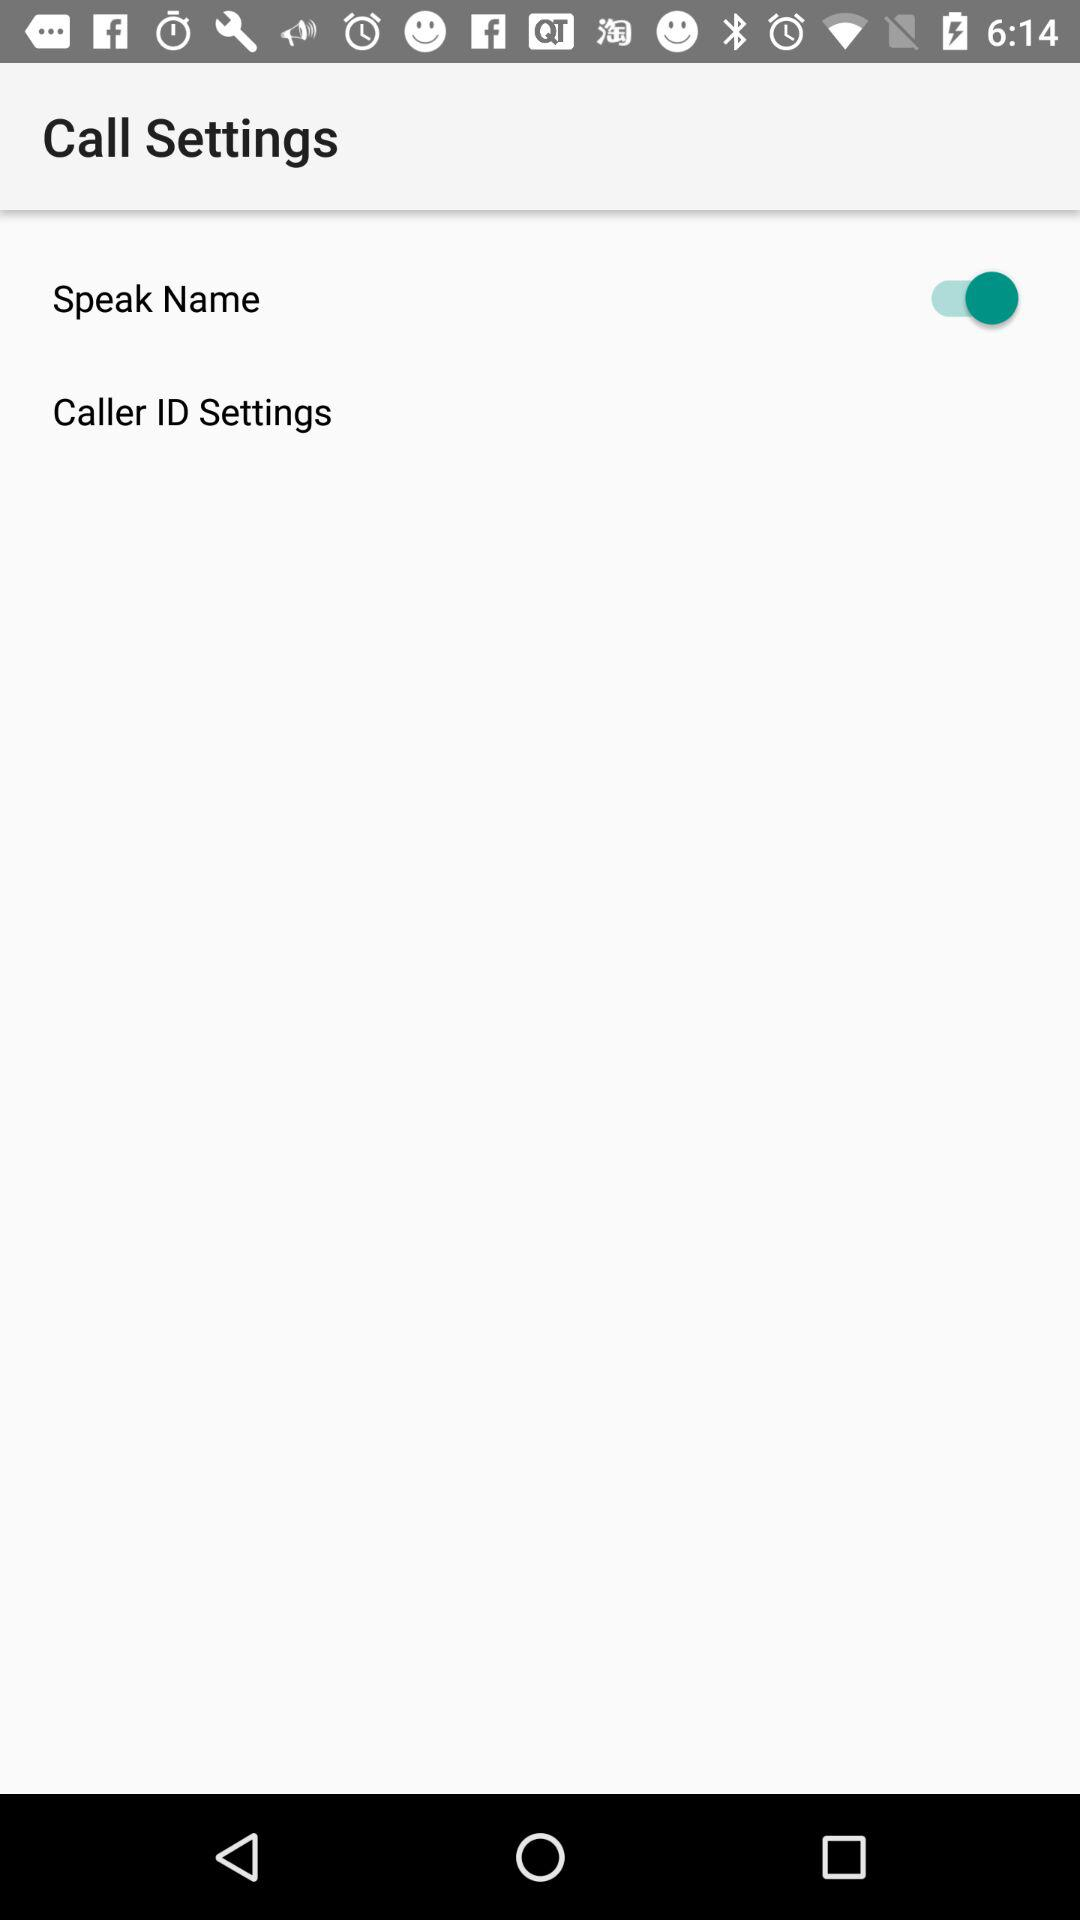What is the status of the "Speak Name" call settings? The status is "on". 